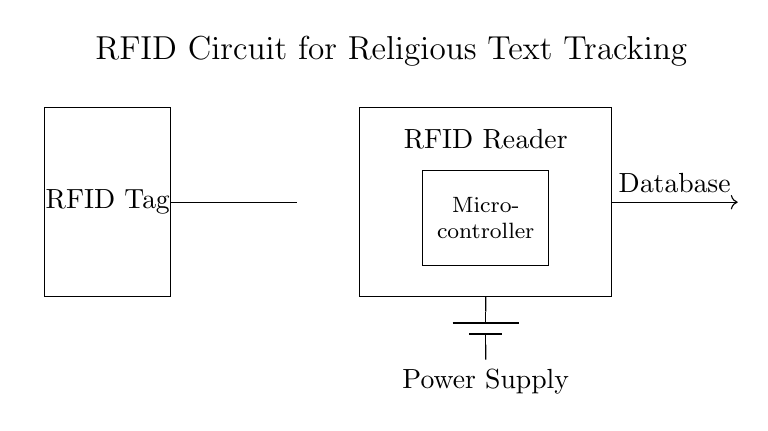What type of circuit is this? This circuit is an RFID circuit specifically designed for tracking and organizing religious text volumes. It includes components like an RFID tag, antenna, RFID reader, microcontroller, and power supply.
Answer: RFID circuit What component receives signals from the RFID tag? The RFID antenna is responsible for receiving signals from the RFID tag. It acts as an interface to collect data from the RFID tag when in proximity.
Answer: Antenna What is the function of the microcontroller in this circuit? The microcontroller processes the data received from the RFID reader and can relay that information to a database for organization and tracking purposes.
Answer: Processing data What powers the circuit? The circuit is powered by a battery, which is indicated as the power supply in the diagram. It provides the necessary voltage and current to the components.
Answer: Battery How many main components are in the circuit? The circuit diagram shows five main components: RFID Tag, Antenna, RFID Reader, Microcontroller, and Power Supply. This totals them for understanding the system structure.
Answer: Five What does the arrow toward the database represent? The arrow indicates a connection or data flow from the RFID reader through the microcontroller to the database, signifying that information is being sent for organization.
Answer: Data flow What is the purpose of the RFID reader? The RFID reader’s purpose is to read the information from the RFID tags associated with religious texts, enabling tracking and organization of those volumes.
Answer: Reading tags 